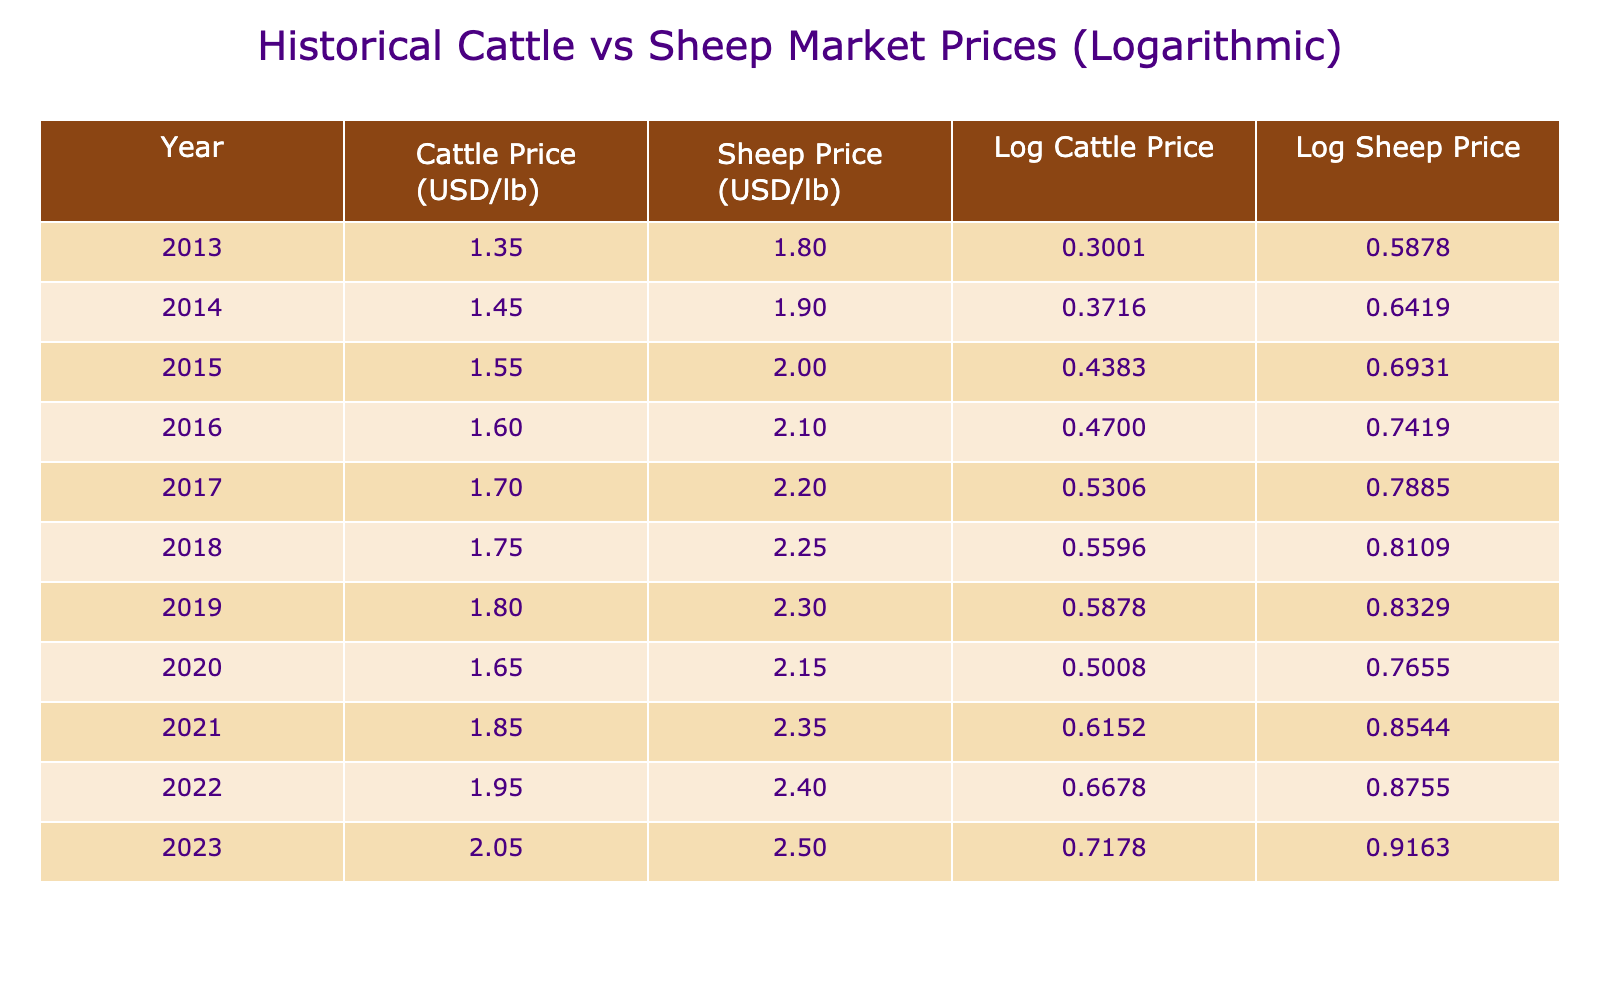What was the highest cattle price recorded in the table? According to the table, the highest cattle price can be found by looking at the "Cattle Price (USD per lb)" column. The prices increase over the years, with the last entry for 2023 showing the highest price of 2.05.
Answer: 2.05 In which year did the sheep price first exceed 2.25? By examining the "Sheep Price (USD per lb)" column, we can identify that the price first exceeds 2.25 in the year 2019 when the price is 2.30.
Answer: 2019 What is the difference between the cattle price and sheep price in 2021? To find the difference for 2021, subtract the "Cattle Price (USD per lb)" from the "Sheep Price (USD per lb)". In 2021, the sheep price is 2.35 and the cattle price is 1.85. The difference is 2.35 - 1.85 = 0.50.
Answer: 0.50 What is the average sheep price over the decade? The average can be calculated by adding all the yearly sheep prices and dividing by the number of years. The total is (1.80 + 1.90 + 2.00 + 2.10 + 2.20 + 2.25 + 2.30 + 2.15 + 2.35 + 2.40 + 2.50) = 23.05. There are 11 years, so the average is 23.05 / 11 ≈ 2.095.
Answer: 2.095 Is it true that the cattle price has increased every year? Analyzing the "Cattle Price (USD per lb)" column shows a consistent increase from 2013 to 2019, but there is a decrease to 1.65 in 2020 before it returns to increasing in subsequent years. Therefore, it is not true that the cattle price has increased every year.
Answer: No Which year showed the largest increase in sheep price compared to the previous year? To find the largest increase, we'll calculate the year-to-year price difference for the sheep prices. The increases are 0.10 (2014), 0.10 (2015), 0.10 (2016), 0.10 (2017), and 0.05 (2018-2019), 0.05 (2019-2020), 0.20 (2020-2021), 0.05 (2021-2022), and 0.10 (2022-2023). The largest increase is 0.20 between 2020 and 2021.
Answer: 2021 What was the overall trend in cattle prices from 2013 to 2023? The trend can be determined by reviewing the values in the "Cattle Price (USD per lb)" column from 2013 to 2023. Starting at 1.35 in 2013 and reaching 2.05 in 2023 indicates a general upward trend, despite a small dip in 2020.
Answer: Upward trend How much did the sheep prices increase from 2013 to 2023? The increase in sheep prices can be found by subtracting the price in 2013 from the price in 2023. Thus, 2.50 - 1.80 = 0.70 indicates the total increase over the decade.
Answer: 0.70 